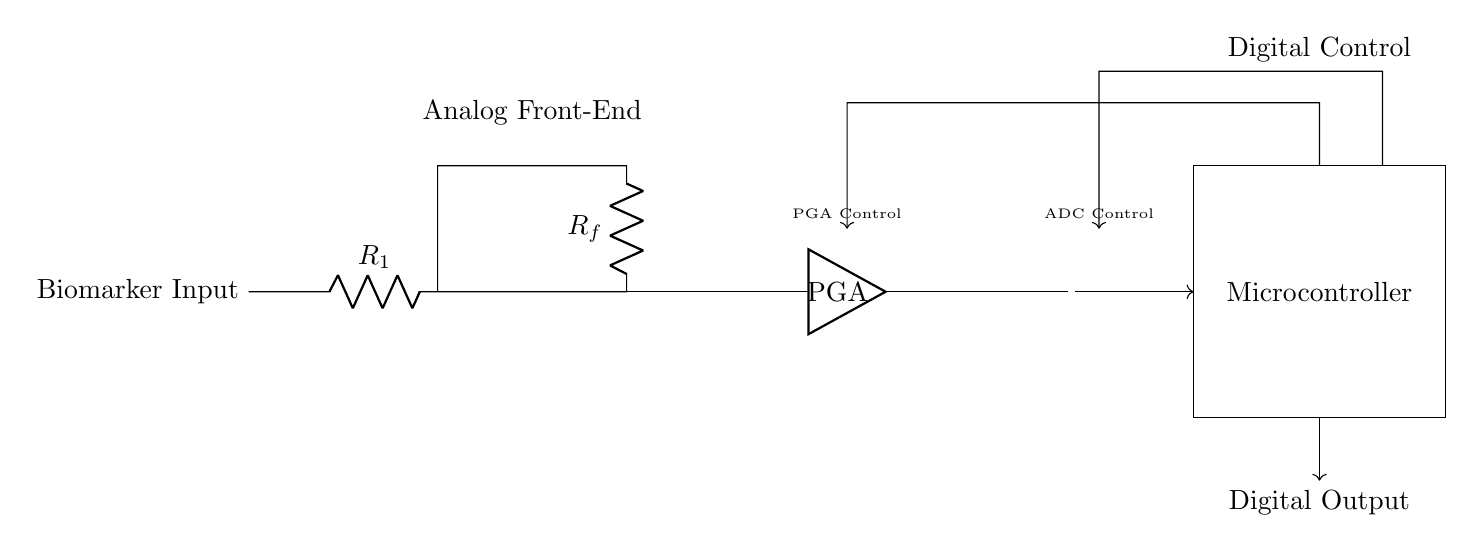What is the function of the op amp in this circuit? The op amp serves as a voltage amplifier, increasing the signal from the biomarker input, which is essential for accurate measurement.
Answer: Voltage amplifier What type of amplifier is used after the op amp? The type of amplifier used is a programmable gain amplifier, which allows for adjustments in gain settings to optimize detection.
Answer: Programmable gain amplifier How many control lines are present in the circuit? There are two control lines, one for the programmable gain amplifier and one for the ADC, which indicate control pathways in the design.
Answer: Two What is the output type of the ADC in this circuit? The output type of the ADC is digital, converting the analog signals into a format that can be processed by the microcontroller.
Answer: Digital What does the rectangle labeled "Microcontroller" represent? The rectangle represents a microcontroller, which is responsible for processing the digital output and controlling the overall system.
Answer: Microcontroller What connects the ADC to the microcontroller? A digital connection, indicated by a directed arrow, connects the ADC to the microcontroller, facilitating data transmission.
Answer: Digital connection What is the purpose of the resistors R1 and Rf in this circuit? R1 and Rf set the input impedance and feedback gain of the op amp, respectively, ensuring proper signal handling for amplification.
Answer: Set input impedance and feedback gain 